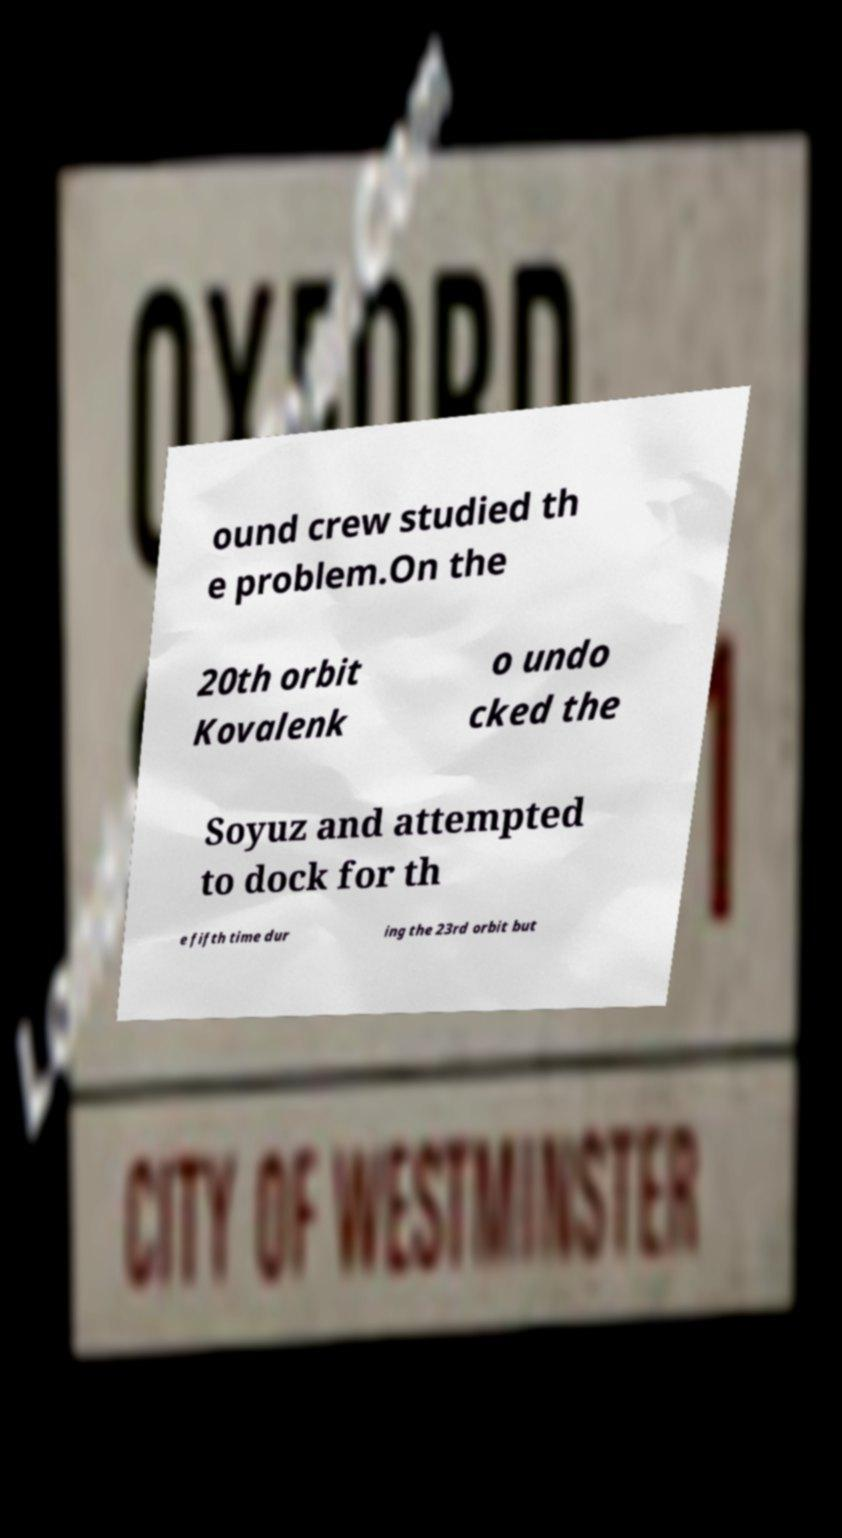There's text embedded in this image that I need extracted. Can you transcribe it verbatim? ound crew studied th e problem.On the 20th orbit Kovalenk o undo cked the Soyuz and attempted to dock for th e fifth time dur ing the 23rd orbit but 